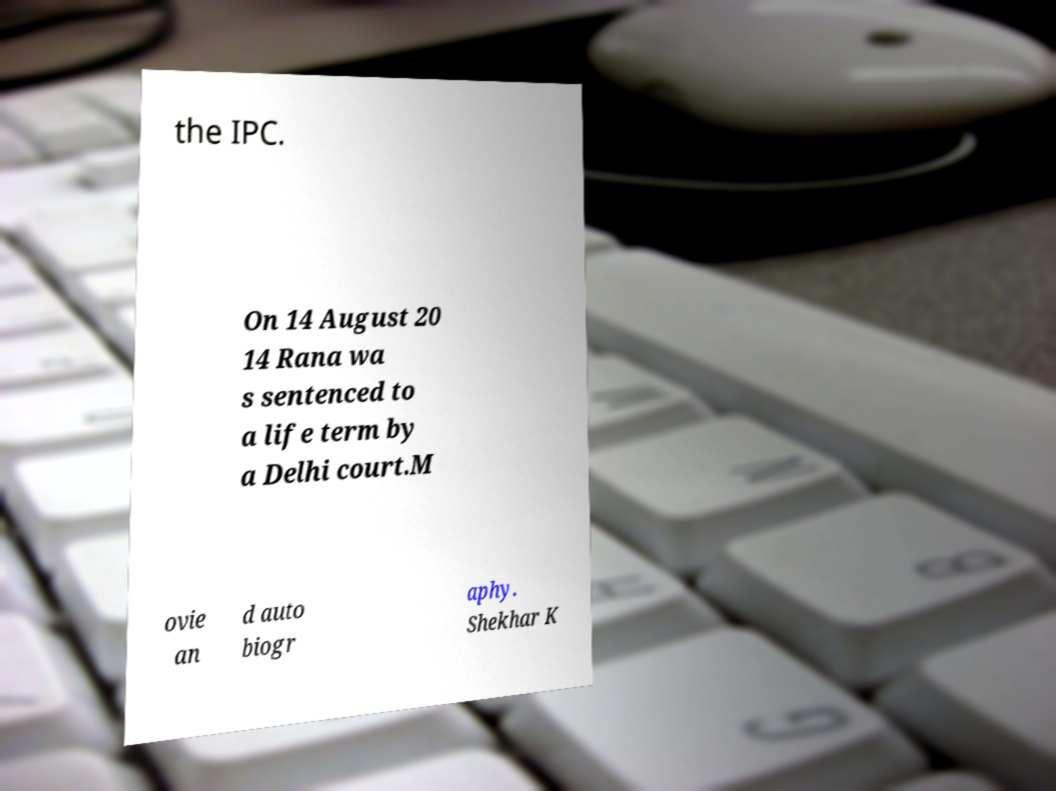I need the written content from this picture converted into text. Can you do that? the IPC. On 14 August 20 14 Rana wa s sentenced to a life term by a Delhi court.M ovie an d auto biogr aphy. Shekhar K 